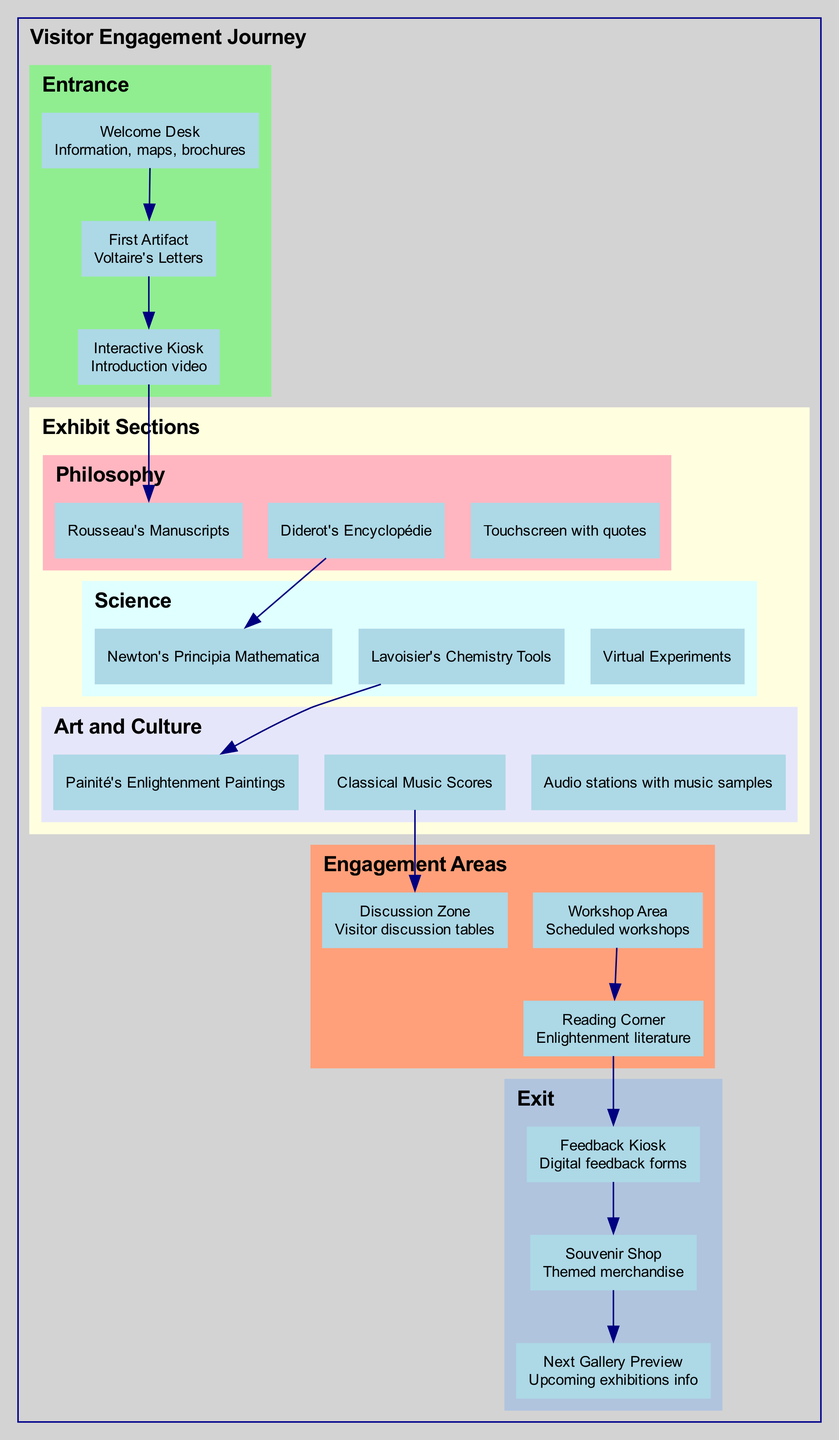What is the first artifact presented to visitors? The diagram states that the first artifact presented to visitors after the welcome desk is "Voltaire's Letters." This is a direct flow from the Welcome Desk to the First Artifact node.
Answer: Voltaire's Letters How many sections are there under Exhibit Sections? The diagram clearly divides Exhibit Sections into three categories: Philosophy, Science, and Art and Culture. Counting these categories gives us a total of three sections.
Answer: 3 What artifact is associated with the Science section? In the diagram, two artifacts are directly listed under the Science section: "Newton's Principia Mathematica" and "Lavoisier’s Chemistry Tools." This indicates that these artifacts represent the scientific contributions of the Enlightenment period.
Answer: Newton's Principia Mathematica What displays can visitors engage with in the Art and Culture section? According to the diagram, the Art and Culture section features an interactive display labeled "Audio stations with samples of Enlightenment music." This shows the interactive engagement provided specifically for this section.
Answer: Audio stations with samples of Enlightenment music What is the final area visitors encounter before exiting? The last node connected before the Exit section is the "Feedback Kiosk." This indicates that visitors are engaged at this kiosk just before they proceed to exit.
Answer: Feedback Kiosk Which engagement area focuses on reading literature? The diagram identifies the "Reading Corner" as an engagement area dedicated to literature. This area allows visitors to read selected works from the Enlightenment period.
Answer: Reading Corner What type of feedback mechanism is available for visitors? The diagram states that visitors can provide feedback through a "Digital feedback forms" available at the Feedback Kiosk. This is a mechanism for gathering visitor experiences in a digital format.
Answer: Digital feedback forms What is the flow of engagement from the Workshop Area? According to the diagram, the Workshop Area connects to the Reading Corner, suggesting that engagement continues from participatory activities in workshops to a more reflective space for reading.
Answer: Reading Corner How many interactive displays are highlighted in the Science section? The Science section mentions one interactive display, which is "Virtual Experiments demonstrating key scientific principles." This indicates a singular focus on interactive engagement through virtual experiments in this section.
Answer: 1 